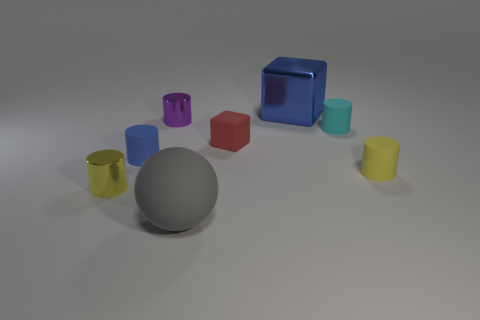Do the blue object in front of the blue metallic cube and the blue metal object have the same size?
Your answer should be very brief. No. What number of spheres are either gray rubber objects or blue rubber objects?
Keep it short and to the point. 1. There is a small yellow cylinder that is to the right of the yellow shiny thing; what is it made of?
Make the answer very short. Rubber. Are there fewer large purple cubes than large blue metal objects?
Keep it short and to the point. Yes. There is a object that is both behind the cyan object and on the right side of the gray rubber object; what is its size?
Ensure brevity in your answer.  Large. There is a metallic thing that is behind the purple cylinder right of the thing that is left of the small blue thing; how big is it?
Your answer should be very brief. Large. How many other things are there of the same color as the big shiny thing?
Provide a succinct answer. 1. Is the color of the small rubber object that is left of the rubber sphere the same as the large metallic block?
Your response must be concise. Yes. How many objects are blue matte cylinders or small matte objects?
Ensure brevity in your answer.  4. The big thing that is behind the tiny blue rubber object is what color?
Keep it short and to the point. Blue. 